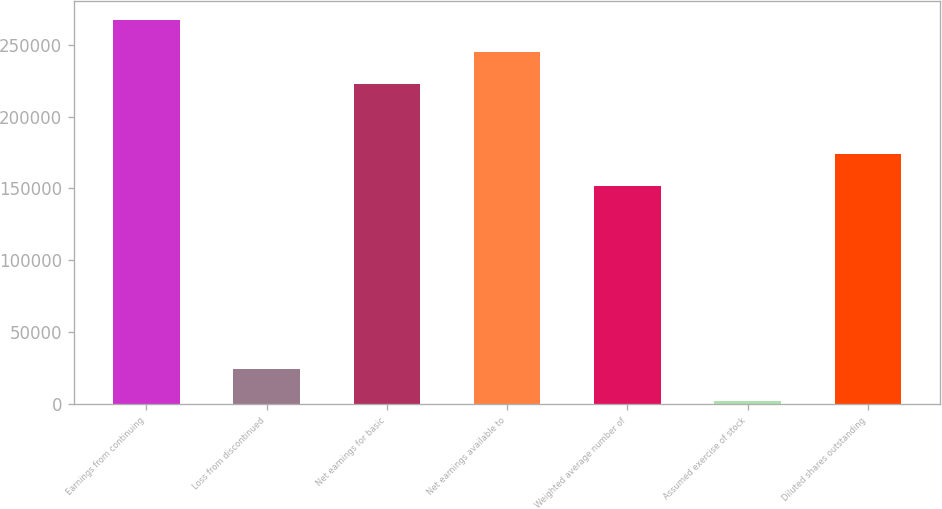<chart> <loc_0><loc_0><loc_500><loc_500><bar_chart><fcel>Earnings from continuing<fcel>Loss from discontinued<fcel>Net earnings for basic<fcel>Net earnings available to<fcel>Weighted average number of<fcel>Assumed exercise of stock<fcel>Diluted shares outstanding<nl><fcel>267077<fcel>24299.6<fcel>222398<fcel>244738<fcel>151634<fcel>1960<fcel>173974<nl></chart> 